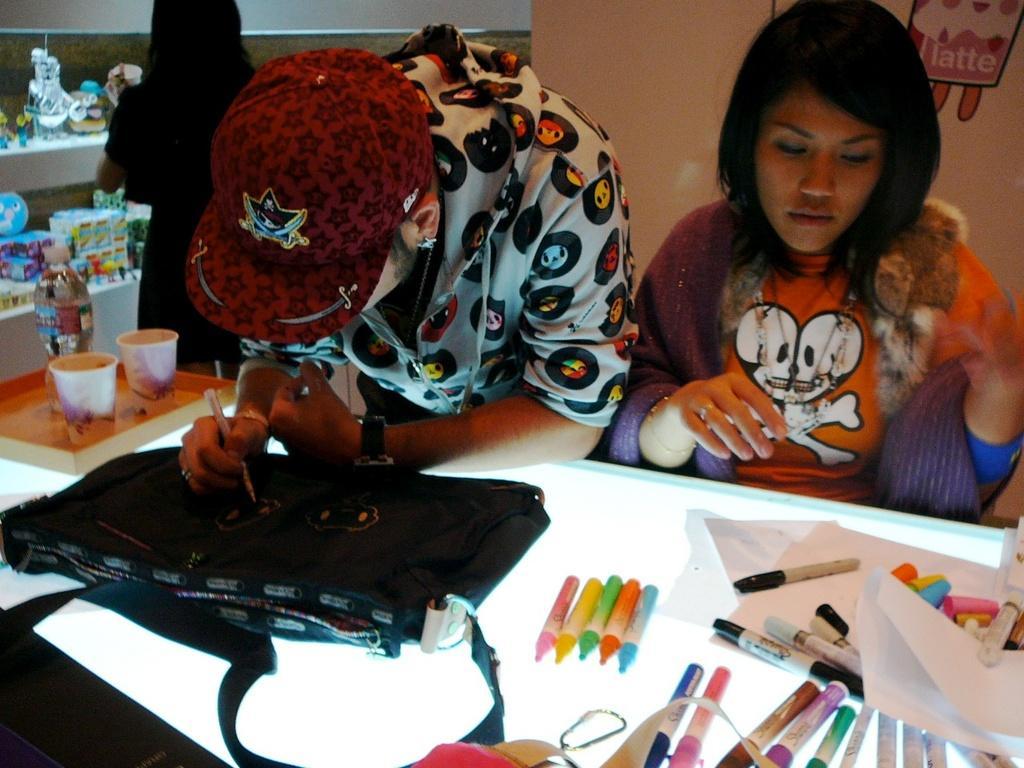Please provide a concise description of this image. In this picture we can see on e person holding pen in his hand and painting on bag and beside to him woman sitting and looking at crayons and sketches placed on a table and in background we can see some person standing and looking at racks with full of toys and here we can see two glasses in tray. 